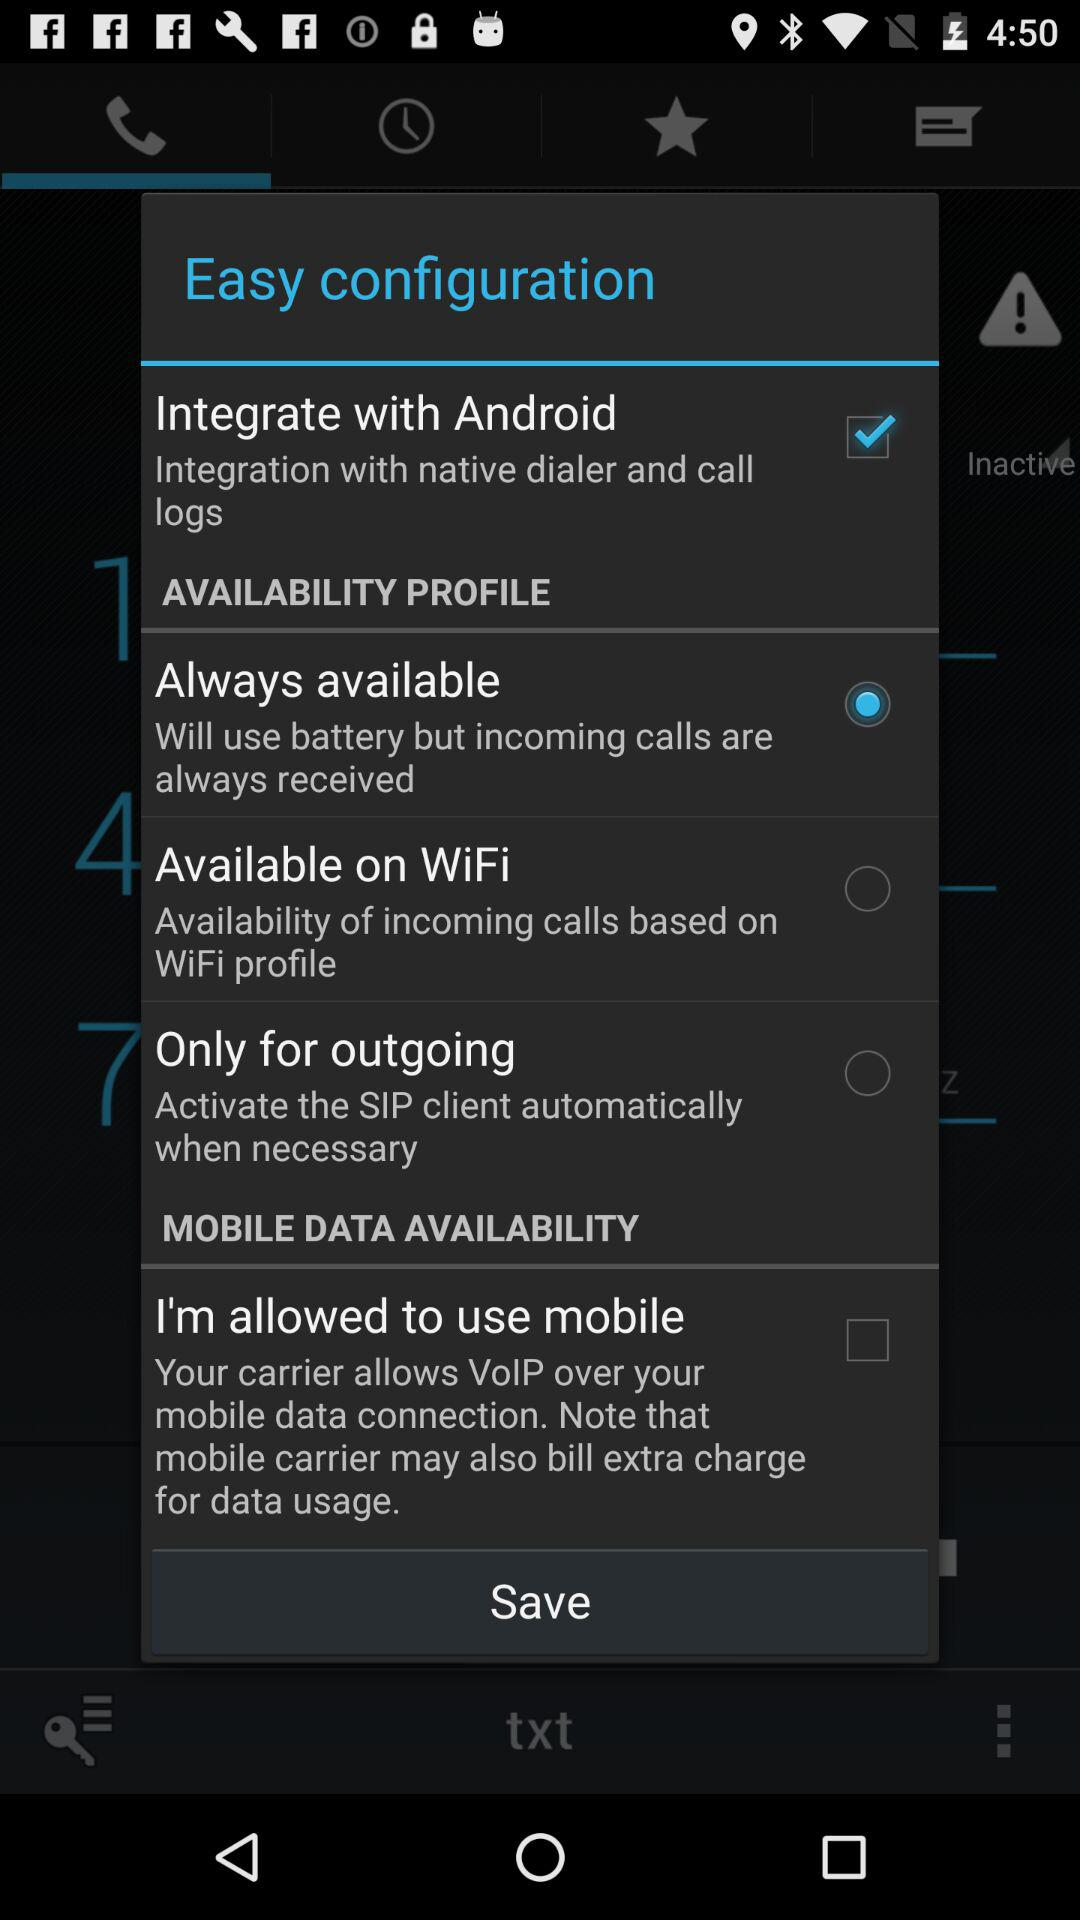What is the status of "Integrate with Android" configuration? The status is "on". 